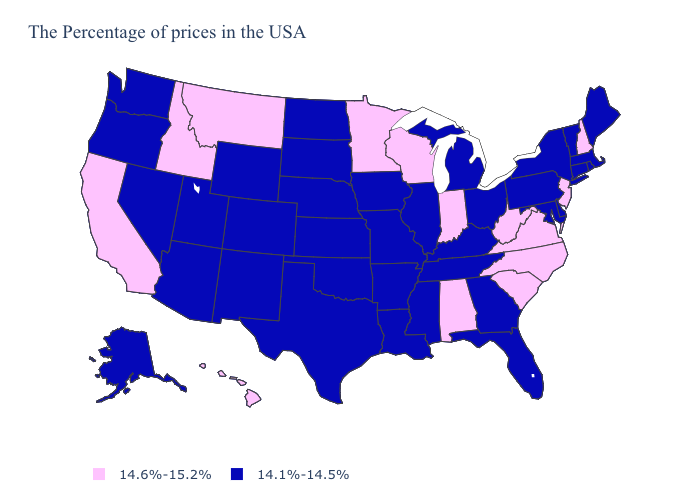How many symbols are there in the legend?
Short answer required. 2. Does the first symbol in the legend represent the smallest category?
Be succinct. No. Name the states that have a value in the range 14.6%-15.2%?
Quick response, please. New Hampshire, New Jersey, Virginia, North Carolina, South Carolina, West Virginia, Indiana, Alabama, Wisconsin, Minnesota, Montana, Idaho, California, Hawaii. Name the states that have a value in the range 14.1%-14.5%?
Short answer required. Maine, Massachusetts, Rhode Island, Vermont, Connecticut, New York, Delaware, Maryland, Pennsylvania, Ohio, Florida, Georgia, Michigan, Kentucky, Tennessee, Illinois, Mississippi, Louisiana, Missouri, Arkansas, Iowa, Kansas, Nebraska, Oklahoma, Texas, South Dakota, North Dakota, Wyoming, Colorado, New Mexico, Utah, Arizona, Nevada, Washington, Oregon, Alaska. What is the value of Iowa?
Keep it brief. 14.1%-14.5%. What is the value of Massachusetts?
Concise answer only. 14.1%-14.5%. Does New Hampshire have the same value as Illinois?
Short answer required. No. Among the states that border Wyoming , does Utah have the highest value?
Keep it brief. No. What is the value of New Hampshire?
Concise answer only. 14.6%-15.2%. What is the value of New Hampshire?
Write a very short answer. 14.6%-15.2%. Does Vermont have a lower value than Virginia?
Short answer required. Yes. Does the map have missing data?
Answer briefly. No. Does South Carolina have the highest value in the South?
Keep it brief. Yes. Does Georgia have the lowest value in the USA?
Answer briefly. Yes. Does the first symbol in the legend represent the smallest category?
Be succinct. No. 